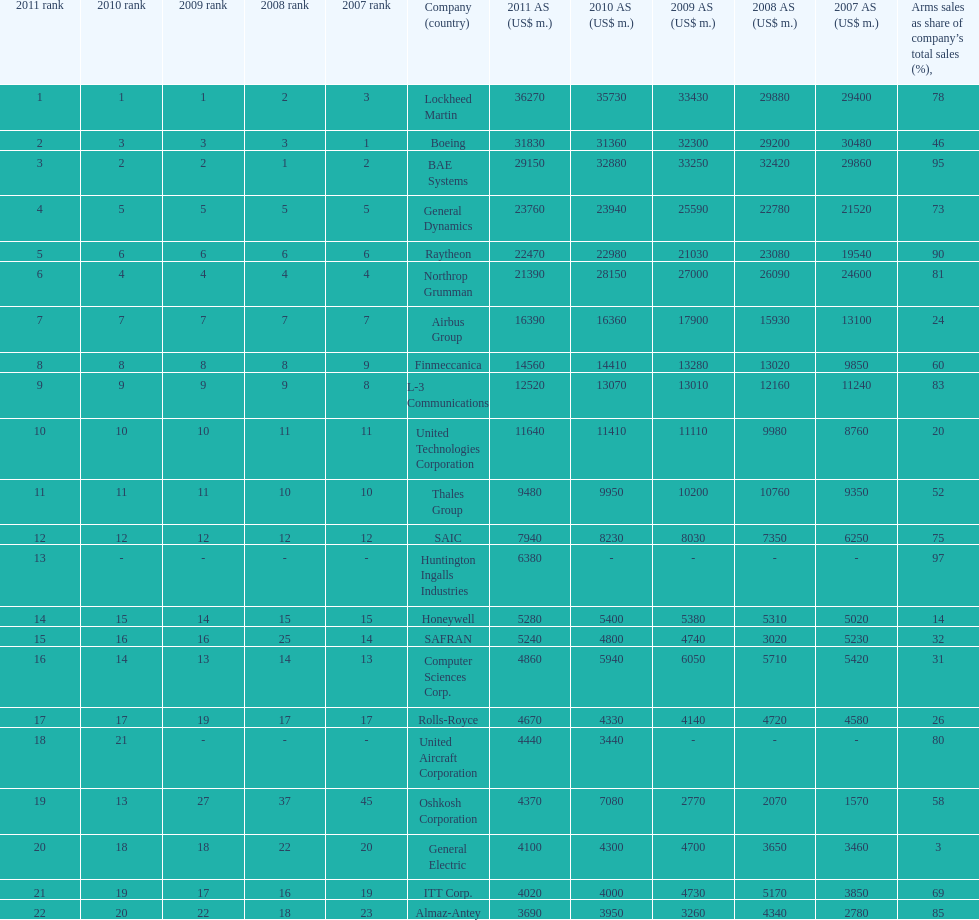How many different countries are listed? 6. 